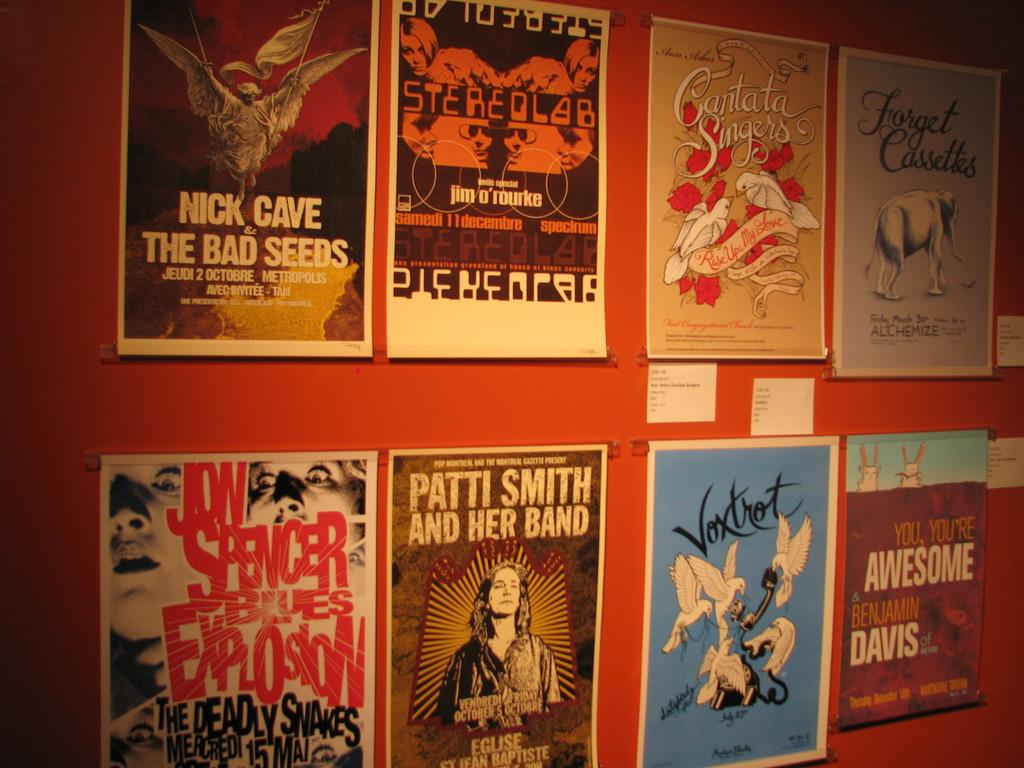<image>
Relay a brief, clear account of the picture shown. A wall lined with posters for performs such as Patti Smith and Jon Spencer. 